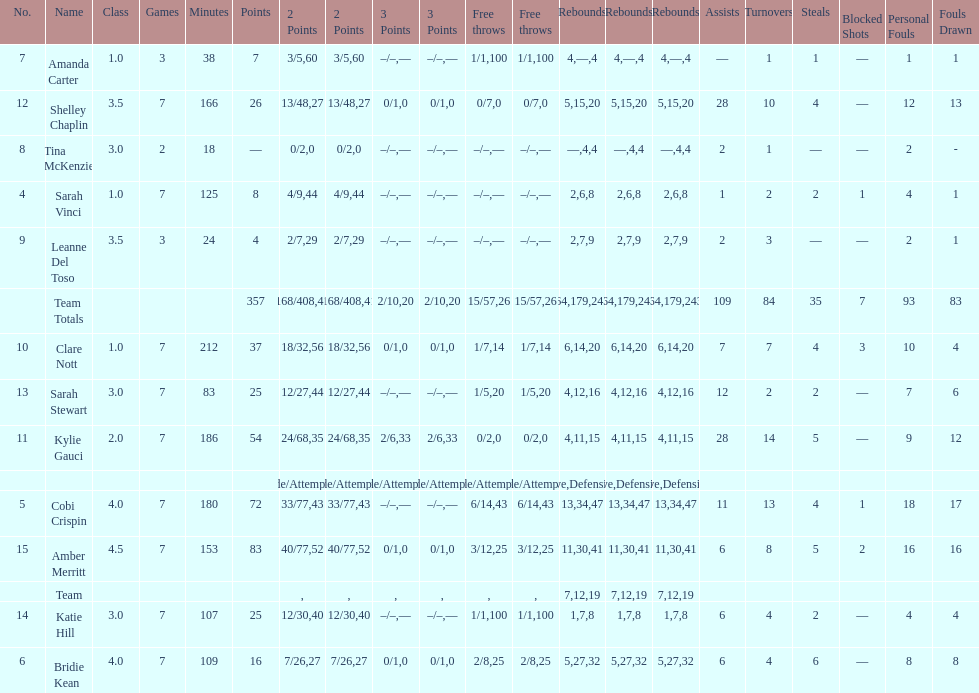Number of 3 points attempted 10. 